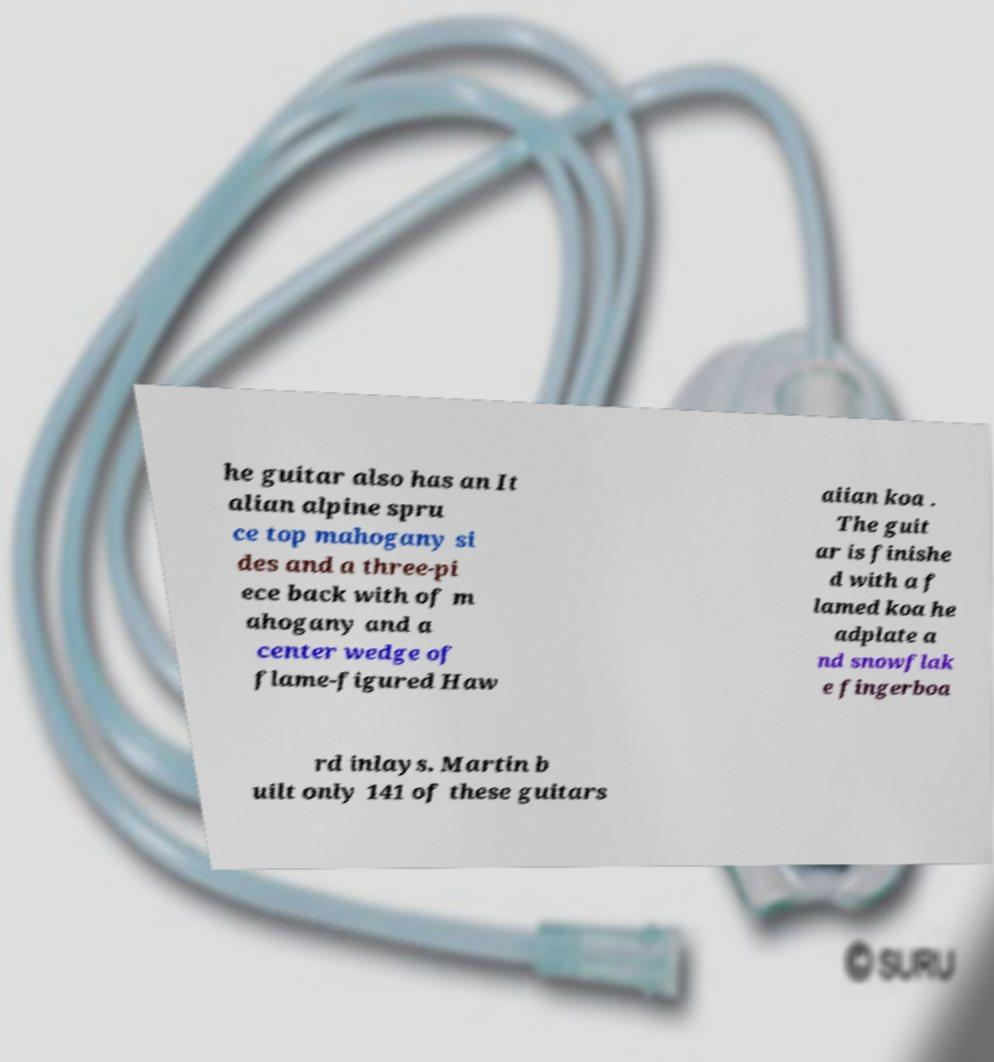Could you assist in decoding the text presented in this image and type it out clearly? he guitar also has an It alian alpine spru ce top mahogany si des and a three-pi ece back with of m ahogany and a center wedge of flame-figured Haw aiian koa . The guit ar is finishe d with a f lamed koa he adplate a nd snowflak e fingerboa rd inlays. Martin b uilt only 141 of these guitars 